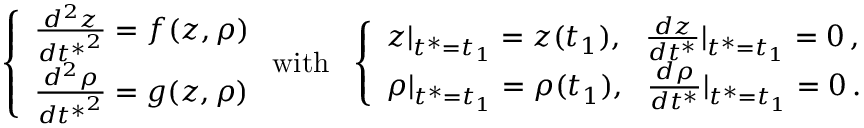<formula> <loc_0><loc_0><loc_500><loc_500>\left \{ \begin{array} { l l } { \frac { d ^ { 2 } z } { { d t ^ { * } } ^ { 2 } } = f ( z , \rho ) } \\ { \frac { d ^ { 2 } \rho } { { d t ^ { * } } ^ { 2 } } = g ( z , \rho ) } \end{array} w i t h \quad l e f t \{ \begin{array} { l l } { z | _ { t ^ { * } = t _ { 1 } } = z ( t _ { 1 } ) , \quad f r a c { d z } { d t ^ { * } } | _ { t ^ { * } = t _ { 1 } } = 0 \, , } \\ { \rho | _ { t ^ { * } = t _ { 1 } } = \rho ( t _ { 1 } ) , \quad f r a c { d \rho } { d t ^ { * } } | _ { t ^ { * } = t _ { 1 } } = 0 \, . } \end{array}</formula> 